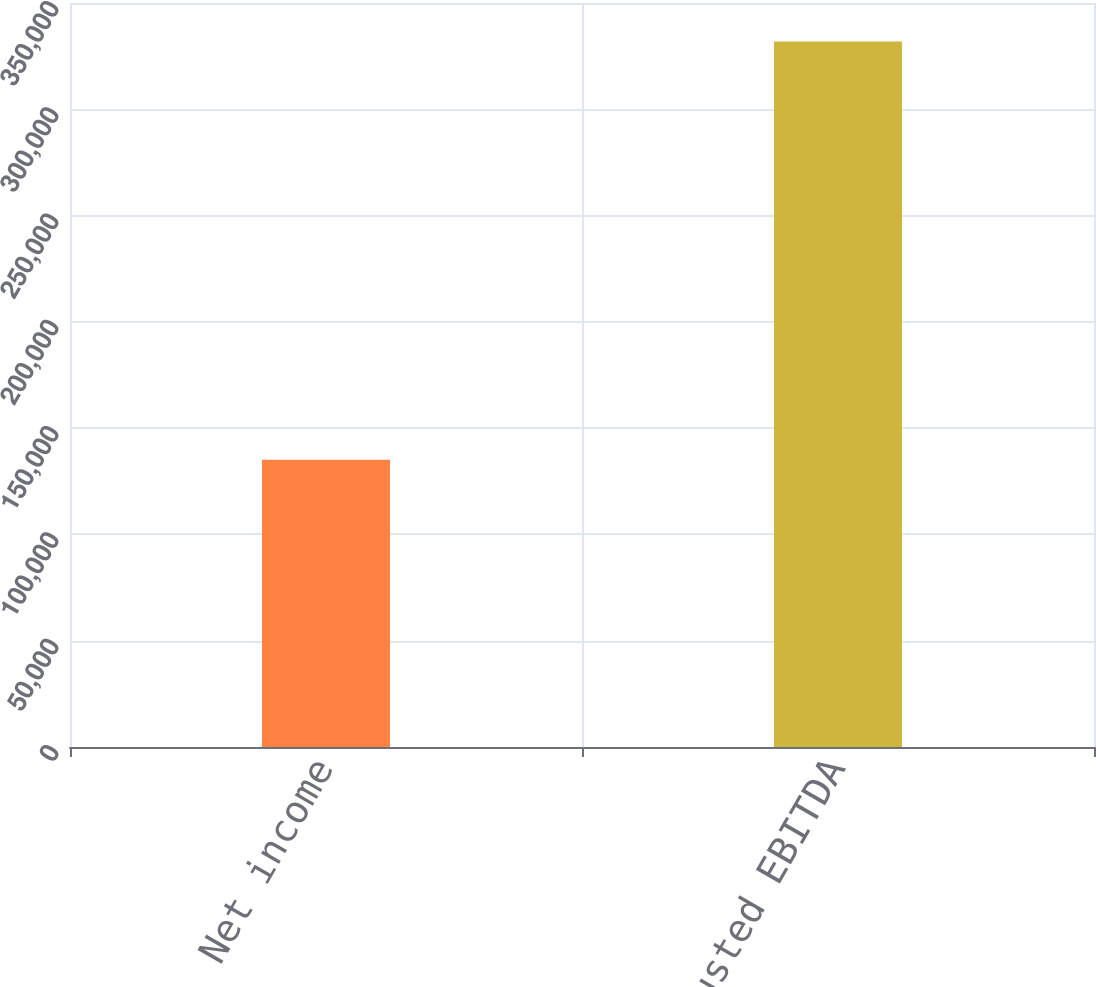Convert chart to OTSL. <chart><loc_0><loc_0><loc_500><loc_500><bar_chart><fcel>Net income<fcel>Adjusted EBITDA<nl><fcel>135153<fcel>331893<nl></chart> 